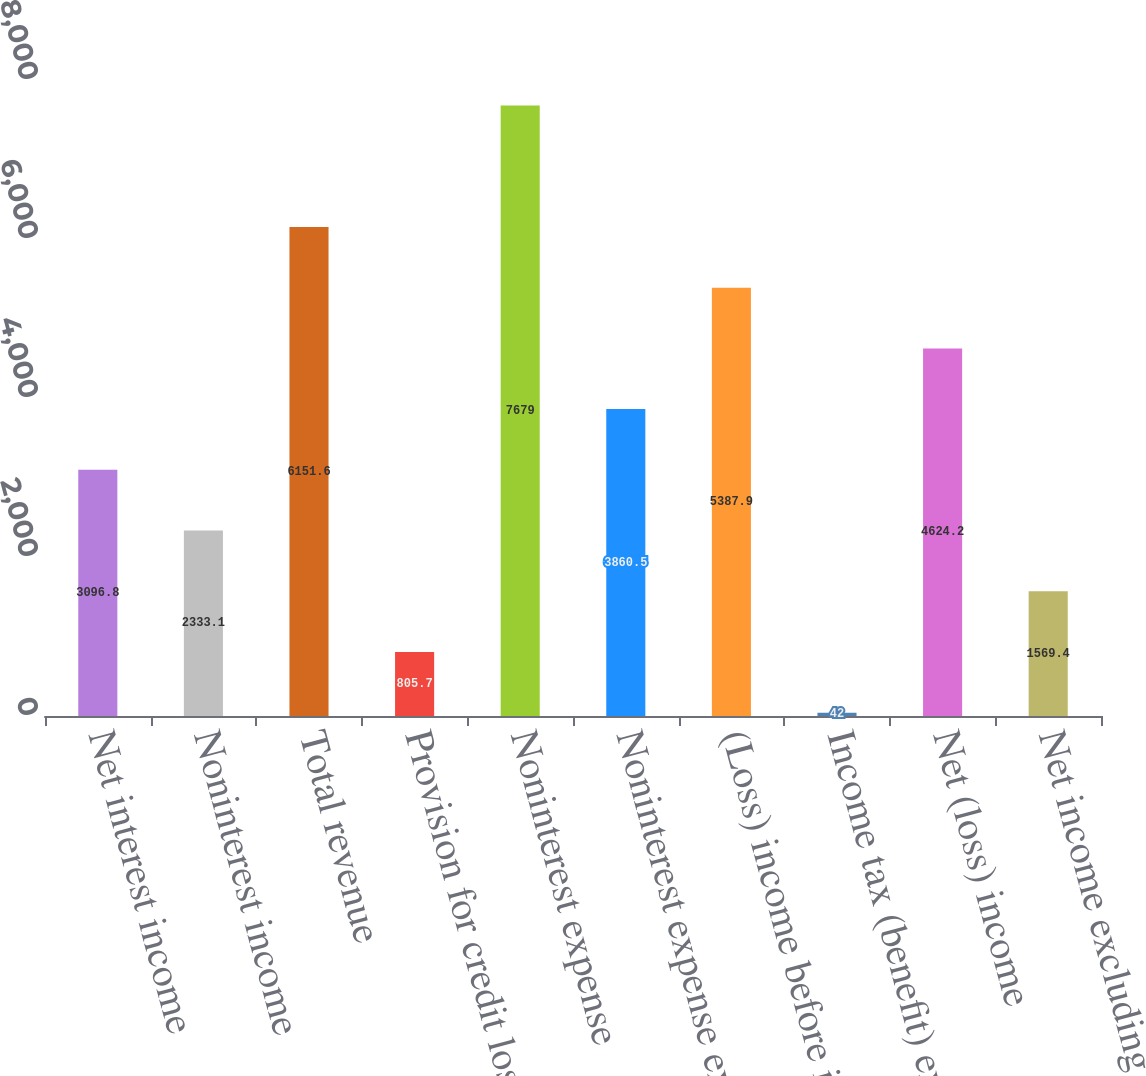<chart> <loc_0><loc_0><loc_500><loc_500><bar_chart><fcel>Net interest income<fcel>Noninterest income<fcel>Total revenue<fcel>Provision for credit losses<fcel>Noninterest expense<fcel>Noninterest expense excluding<fcel>(Loss) income before income<fcel>Income tax (benefit) expense<fcel>Net (loss) income<fcel>Net income excluding goodwill<nl><fcel>3096.8<fcel>2333.1<fcel>6151.6<fcel>805.7<fcel>7679<fcel>3860.5<fcel>5387.9<fcel>42<fcel>4624.2<fcel>1569.4<nl></chart> 